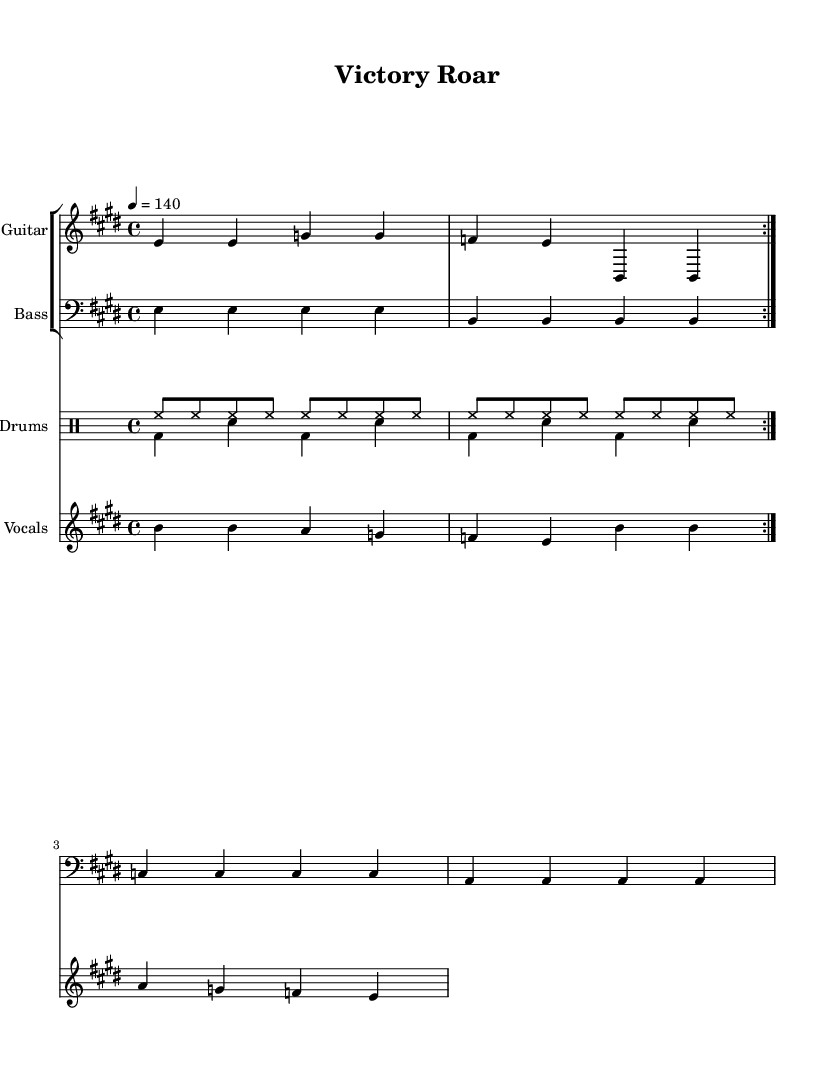What is the key signature of this music? The key signature is E major, which has four sharps: F#, C#, G#, and D#. This can be found at the beginning of the score after the clef.
Answer: E major What is the time signature of the score? The time signature is 4/4, indicating four beats per measure. This is specified at the beginning of the score and is reflected in the rhythmic structure of the music.
Answer: 4/4 What is the tempo marking for this piece? The tempo marking is 140 beats per minute, indicated by the "4 = 140" at the beginning. This dictates the speed at which the piece should be played.
Answer: 140 How many times is the main theme repeated? The main theme is repeated twice, as indicated by the "repeat volta 2" marking in the guitar part, suggesting the section should be played two times.
Answer: 2 What instruments are used in this score? The instruments listed in the score are Guitar, Bass, Drums, and Vocals. These can be seen in the staff groups designated for each instrument.
Answer: Guitar, Bass, Drums, Vocals What is the dynamic feel of the song based on the drum patterns? The drum patterns suggest a strong, driving feel typical of rock music, characterized by the consistent use of hi-hat and bass drum patterns that create an energetic atmosphere, which is ideal for celebrations.
Answer: Energetic 